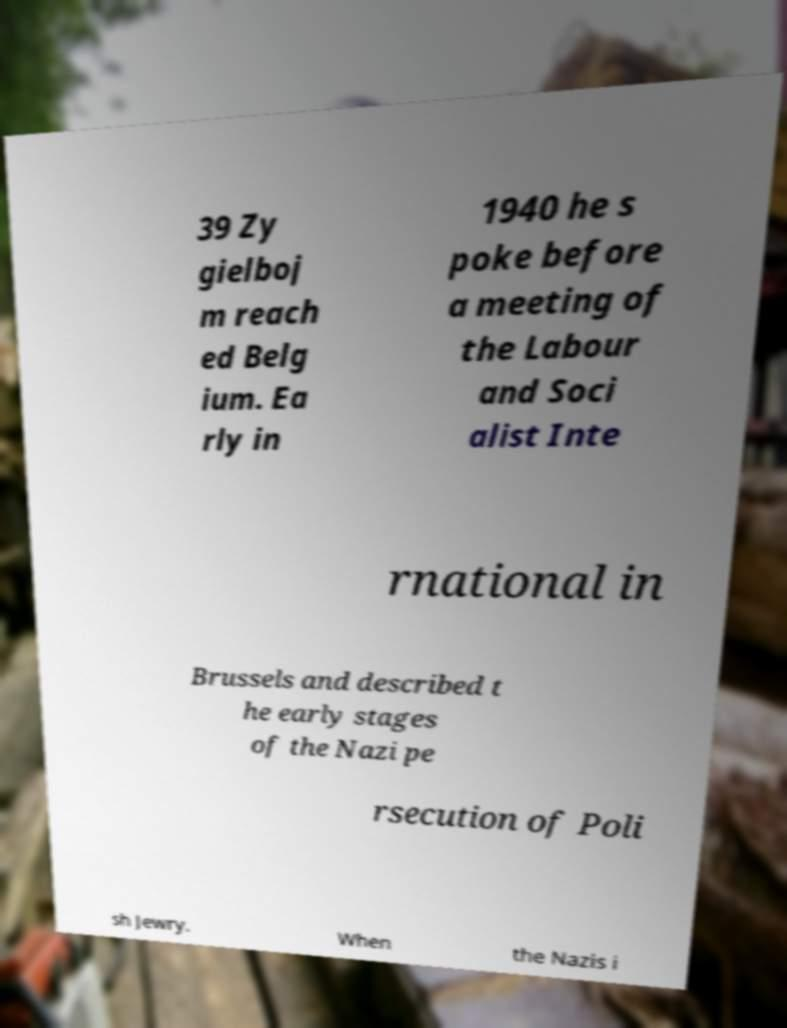What messages or text are displayed in this image? I need them in a readable, typed format. 39 Zy gielboj m reach ed Belg ium. Ea rly in 1940 he s poke before a meeting of the Labour and Soci alist Inte rnational in Brussels and described t he early stages of the Nazi pe rsecution of Poli sh Jewry. When the Nazis i 